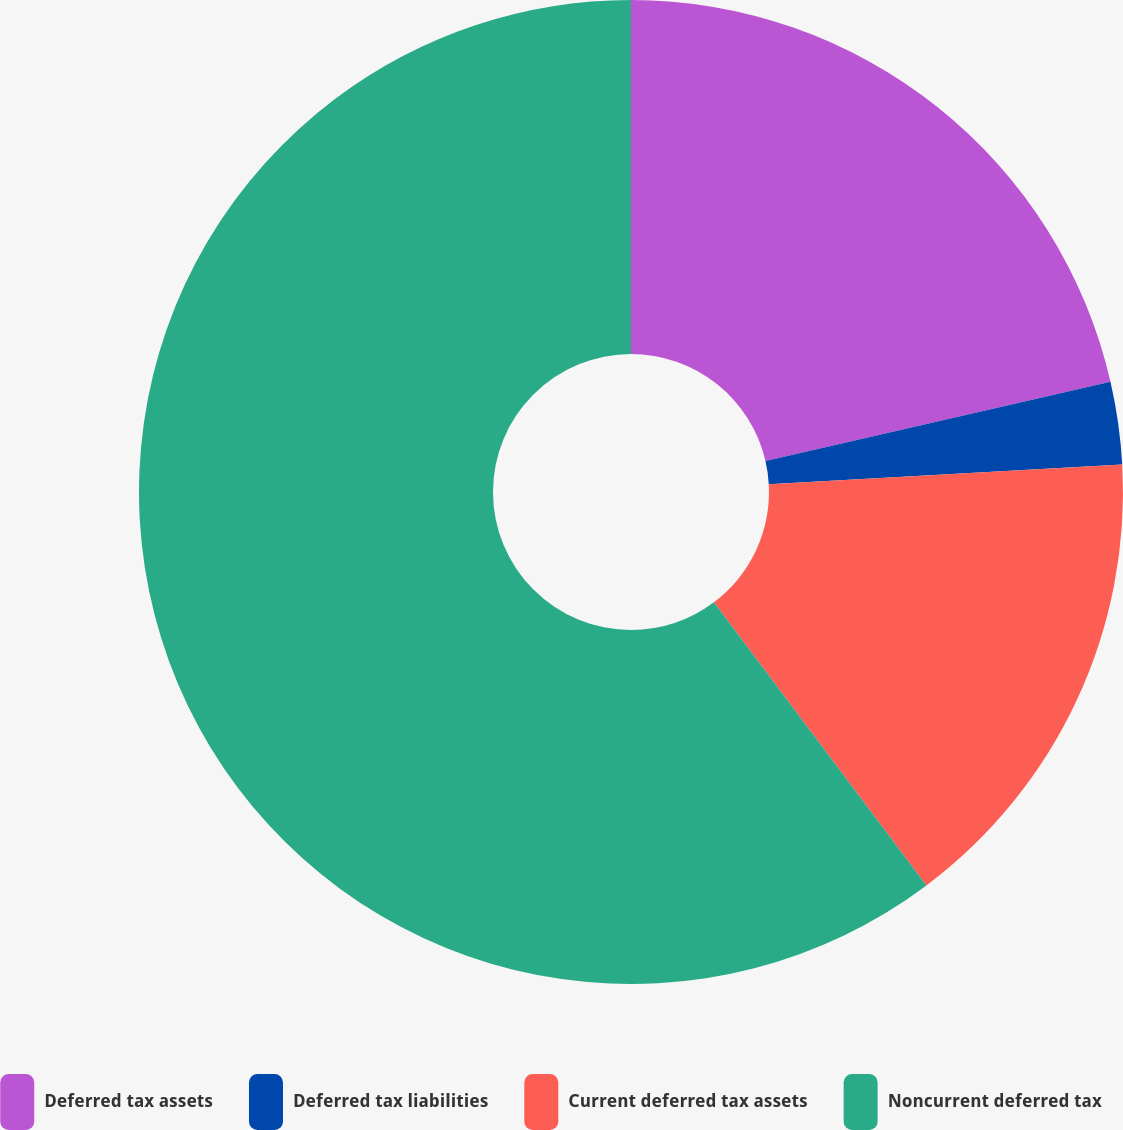Convert chart to OTSL. <chart><loc_0><loc_0><loc_500><loc_500><pie_chart><fcel>Deferred tax assets<fcel>Deferred tax liabilities<fcel>Current deferred tax assets<fcel>Noncurrent deferred tax<nl><fcel>21.4%<fcel>2.71%<fcel>15.64%<fcel>60.25%<nl></chart> 